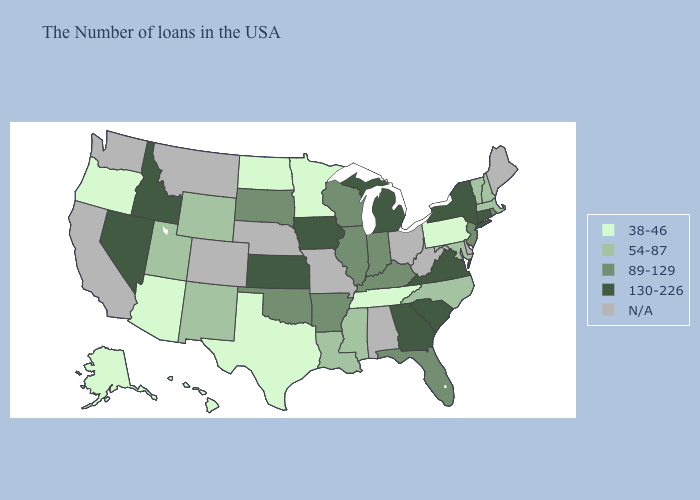Among the states that border Rhode Island , which have the lowest value?
Give a very brief answer. Massachusetts. Does North Dakota have the lowest value in the MidWest?
Write a very short answer. Yes. Among the states that border Louisiana , does Mississippi have the lowest value?
Give a very brief answer. No. Does Minnesota have the highest value in the USA?
Quick response, please. No. Does Tennessee have the lowest value in the USA?
Short answer required. Yes. What is the value of North Carolina?
Give a very brief answer. 54-87. How many symbols are there in the legend?
Write a very short answer. 5. Which states have the highest value in the USA?
Answer briefly. Connecticut, New York, Virginia, South Carolina, Georgia, Michigan, Iowa, Kansas, Idaho, Nevada. What is the value of South Carolina?
Write a very short answer. 130-226. What is the value of Virginia?
Quick response, please. 130-226. What is the value of Nevada?
Write a very short answer. 130-226. Name the states that have a value in the range 130-226?
Write a very short answer. Connecticut, New York, Virginia, South Carolina, Georgia, Michigan, Iowa, Kansas, Idaho, Nevada. Name the states that have a value in the range N/A?
Be succinct. Maine, Delaware, West Virginia, Ohio, Alabama, Missouri, Nebraska, Colorado, Montana, California, Washington. 